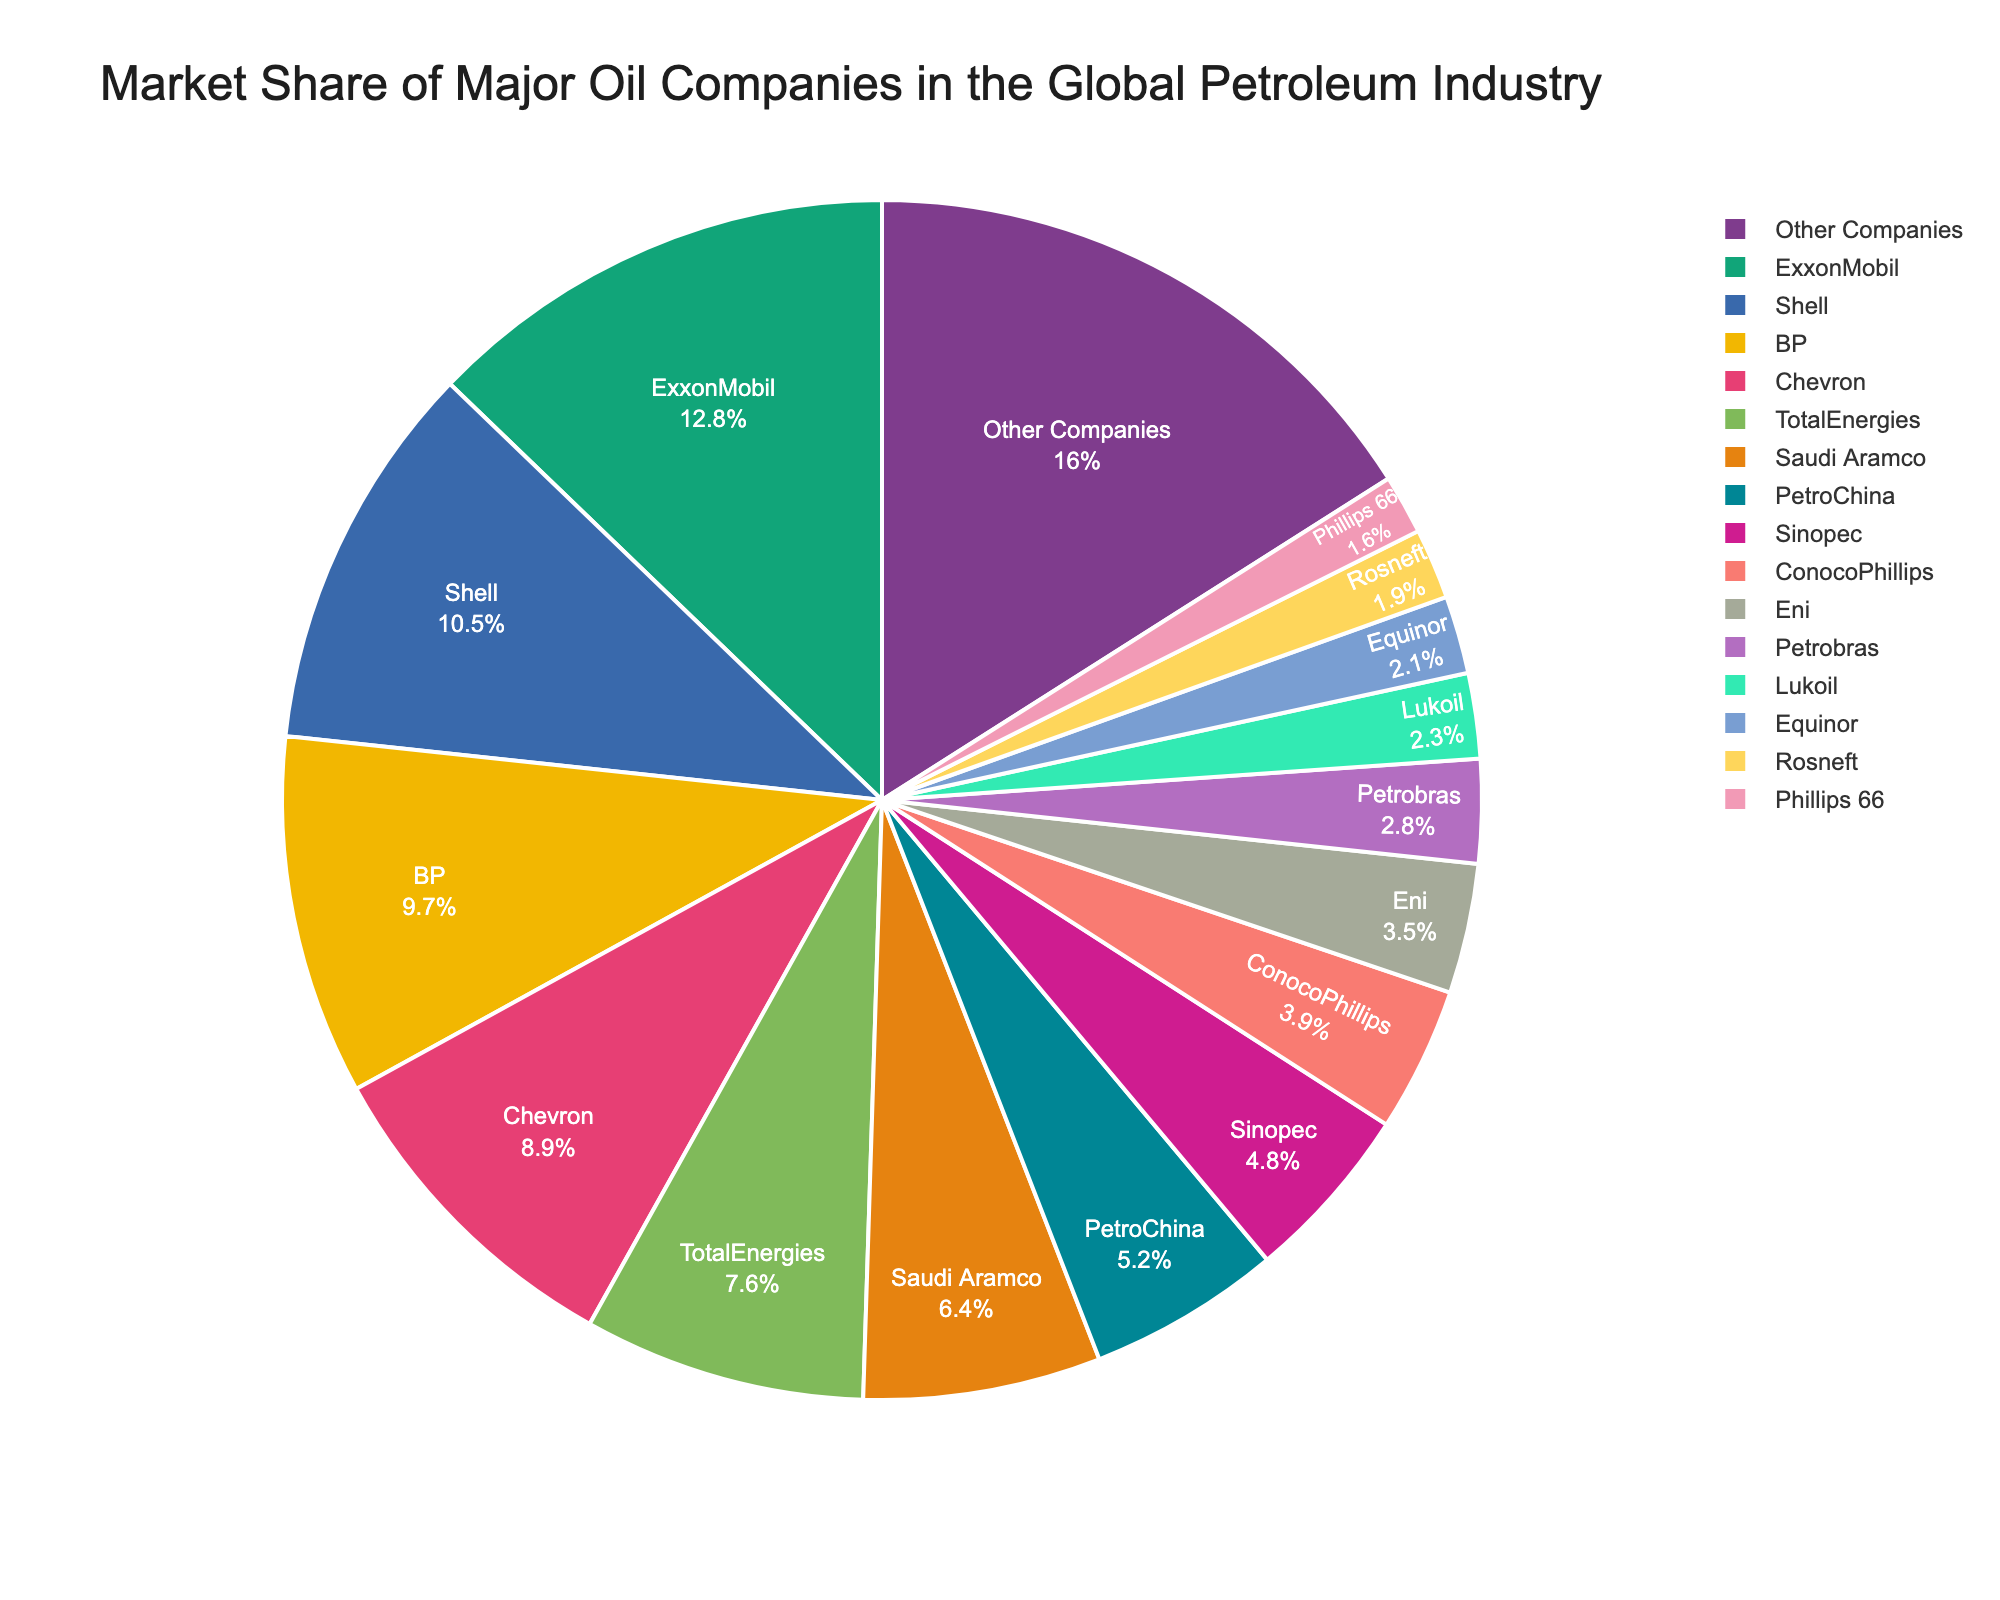Which company has the largest market share? By looking at the pie chart, the company with the largest section represents the largest market share. ExxonMobil's section is the largest at 12.8%.
Answer: ExxonMobil What is the combined market share of Shell and BP? Shell has a market share of 10.5%, and BP has 9.7%. Adding them together gives 10.5% + 9.7% = 20.2%.
Answer: 20.2% How much more market share does ExxonMobil have compared to Chevron? ExxonMobil's market share is 12.8%, and Chevron's is 8.9%. Subtracting these gives 12.8% - 8.9% = 3.9%.
Answer: 3.9% Which three companies have the smallest market shares, and what is their combined total? By reviewing the smallest sections of the chart, the three companies with the smallest market shares are Rosneft (1.9%), Phillips 66 (1.6%), and Equinor (2.1%). Adding them together gives 1.9% + 1.6% + 2.1% = 5.6%.
Answer: Rosneft, Phillips 66, Equinor; 5.6% What is the average market share of ConocoPhillips, Eni, and Petrobras? ConocoPhillips has a market share of 3.9%, Eni has 3.5%, and Petrobras has 2.8%. Adding them together gives 3.9% + 3.5% + 2.8% = 10.2%. Dividing by 3, the average market share is 10.2% / 3 = 3.4%.
Answer: 3.4% How does the market share of TotalEnergies compare to that of Saudi Aramco? TotalEnergies has a market share of 7.6%, and Saudi Aramco has 6.4%. TotalEnergies has a larger market share by 7.6% - 6.4% = 1.2%.
Answer: TotalEnergies has 1.2% more Which company has the market share closest to 5%? By observing the pie chart, the company with the market share closest to 5% is PetroChina with 5.2%.
Answer: PetroChina Combine the market shares of the four companies with the smallest shares. What proportion of the market do they represent collectively? The four companies with the smallest market shares are Rosneft (1.9%), Phillips 66 (1.6%), Equinor (2.1%), and Lukoil (2.3%). Adding them together gives 1.9% + 1.6% + 2.1% + 2.3% = 7.9%.
Answer: 7.9% Which company has a market share twice that of Eni? Eni has a market share of 3.5%. The company with a market share closest to twice that is Chevron with 8.9%, which is approximately 2 * 3.5% = 7%. Chevron's share of 8.9% is not precisely twice but is close.
Answer: Chevron 